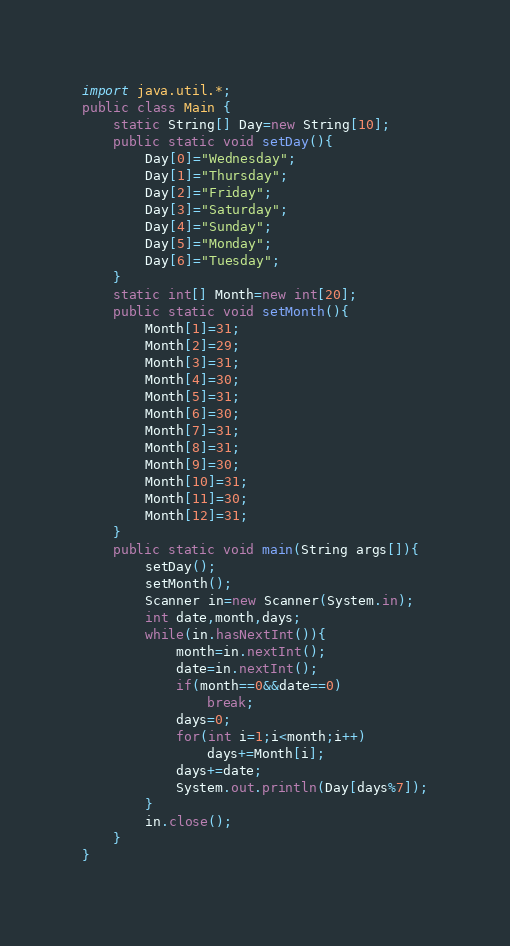<code> <loc_0><loc_0><loc_500><loc_500><_Java_>import java.util.*;
public class Main {
	static String[] Day=new String[10];
	public static void setDay(){
		Day[0]="Wednesday";
		Day[1]="Thursday";
		Day[2]="Friday";
		Day[3]="Saturday";
		Day[4]="Sunday";
		Day[5]="Monday";
		Day[6]="Tuesday";
	}
	static int[] Month=new int[20];
	public static void setMonth(){
		Month[1]=31;
		Month[2]=29;
		Month[3]=31;
		Month[4]=30;
		Month[5]=31;
		Month[6]=30;
		Month[7]=31;
		Month[8]=31;
		Month[9]=30;
		Month[10]=31;
		Month[11]=30;
		Month[12]=31;
	}
	public static void main(String args[]){
		setDay();
		setMonth();
		Scanner in=new Scanner(System.in);
		int date,month,days;
		while(in.hasNextInt()){
			month=in.nextInt();
			date=in.nextInt();
			if(month==0&&date==0)
				break;
			days=0;
			for(int i=1;i<month;i++)
				days+=Month[i];
			days+=date;
			System.out.println(Day[days%7]);
		}
		in.close();
	}
}</code> 